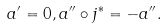Convert formula to latex. <formula><loc_0><loc_0><loc_500><loc_500>a ^ { \prime } = 0 , a ^ { \prime \prime } \circ j ^ { * } = - a ^ { \prime \prime } .</formula> 